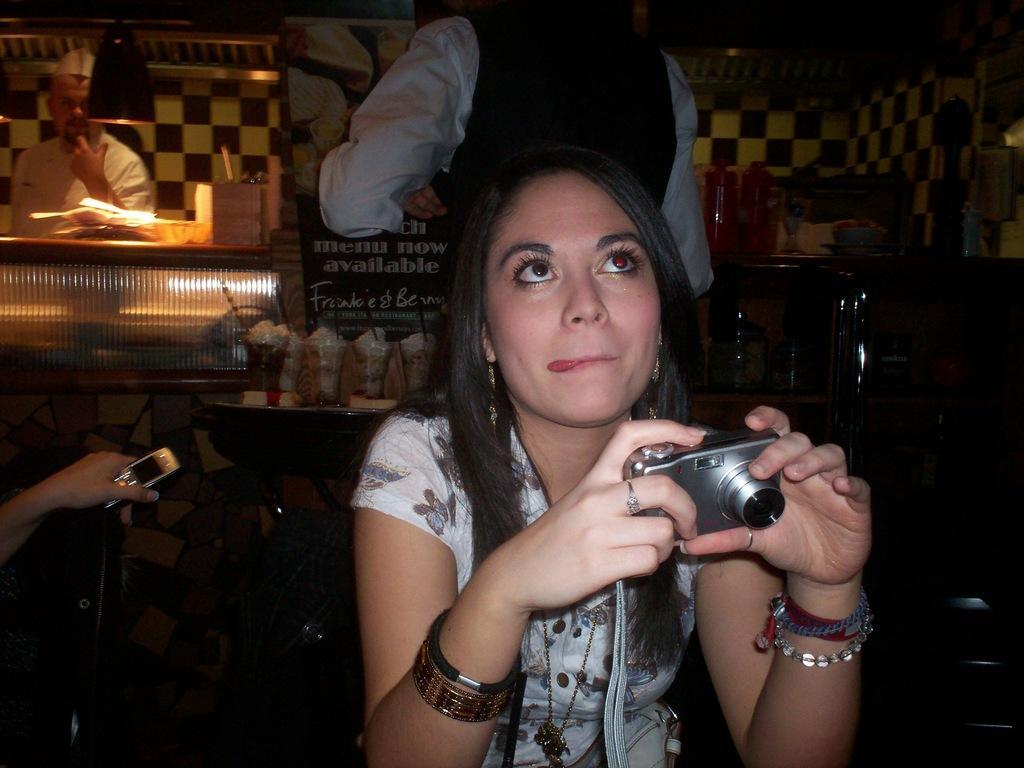How would you summarize this image in a sentence or two? There is a woman sitting and operating camera and behind her there are many. 